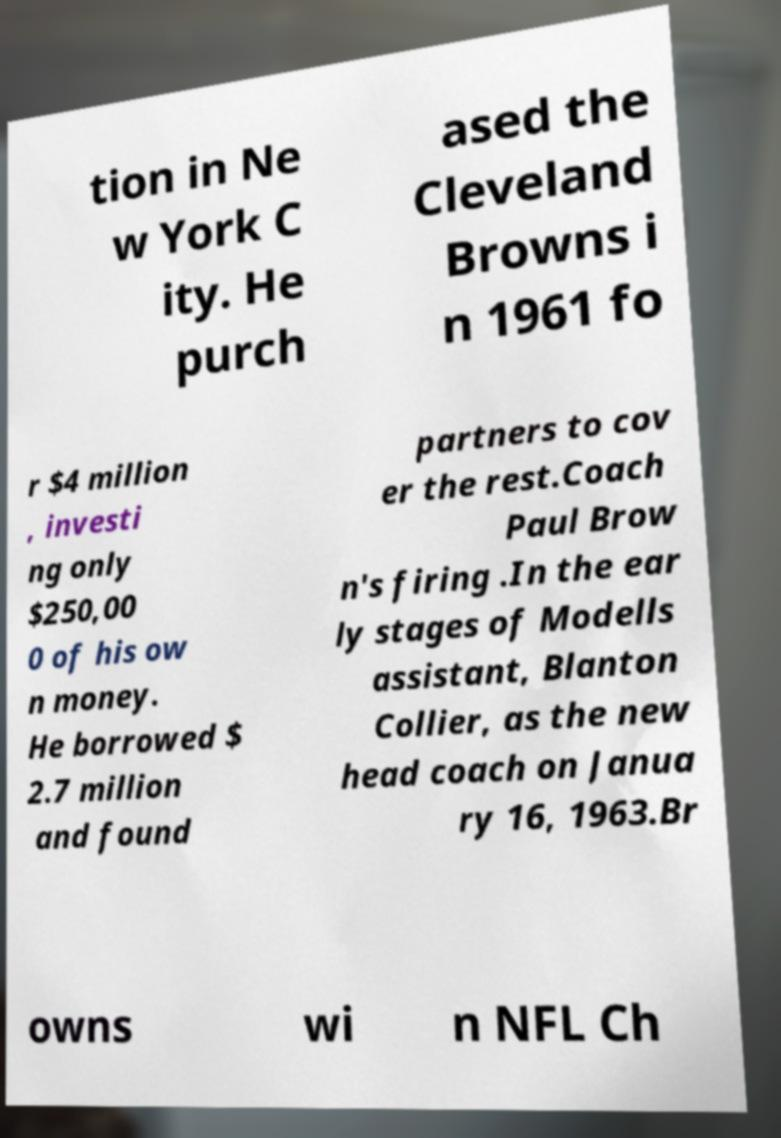There's text embedded in this image that I need extracted. Can you transcribe it verbatim? tion in Ne w York C ity. He purch ased the Cleveland Browns i n 1961 fo r $4 million , investi ng only $250,00 0 of his ow n money. He borrowed $ 2.7 million and found partners to cov er the rest.Coach Paul Brow n's firing .In the ear ly stages of Modells assistant, Blanton Collier, as the new head coach on Janua ry 16, 1963.Br owns wi n NFL Ch 